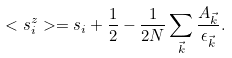<formula> <loc_0><loc_0><loc_500><loc_500>< s _ { i } ^ { z } > = s _ { i } + \frac { 1 } { 2 } - \frac { 1 } { 2 N } \sum _ { \vec { k } } \frac { A _ { \vec { k } } } { \epsilon _ { \vec { k } } } .</formula> 